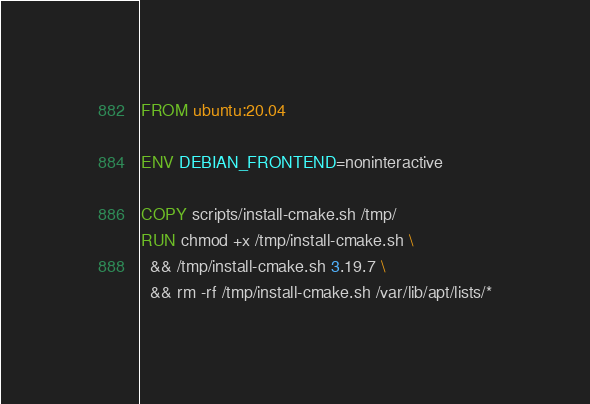Convert code to text. <code><loc_0><loc_0><loc_500><loc_500><_Dockerfile_>FROM ubuntu:20.04

ENV DEBIAN_FRONTEND=noninteractive

COPY scripts/install-cmake.sh /tmp/
RUN chmod +x /tmp/install-cmake.sh \
  && /tmp/install-cmake.sh 3.19.7 \
  && rm -rf /tmp/install-cmake.sh /var/lib/apt/lists/*
</code> 